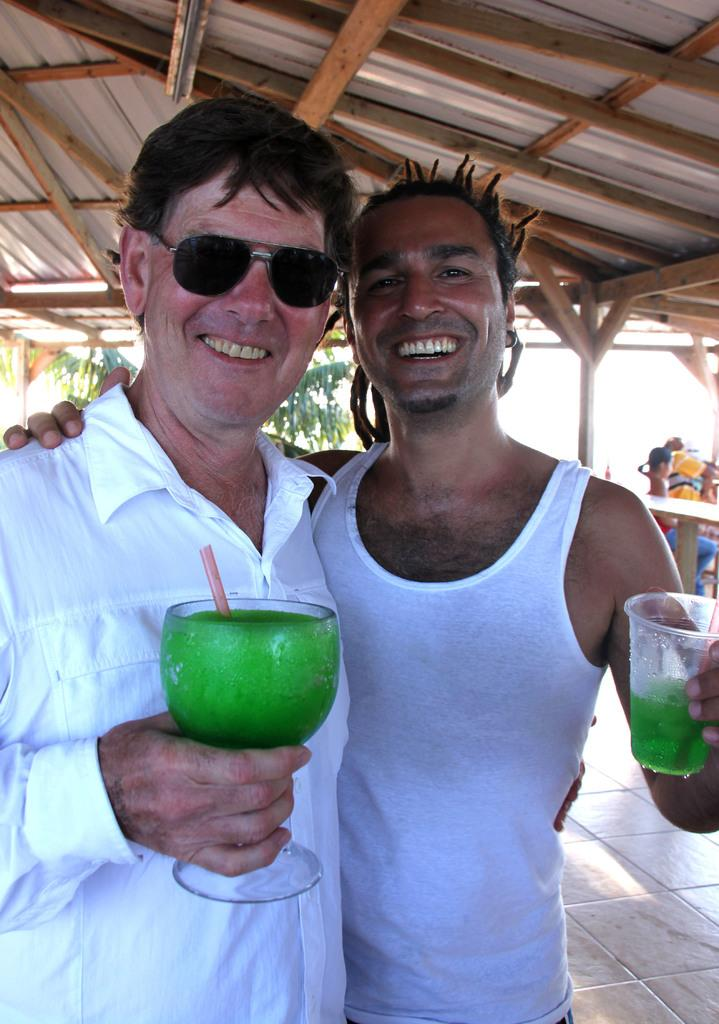How many people are in the image? There are two men in the image. Where are the men located in the image? The men are standing in the middle of the image. What are the men holding in the image? The men are holding green color juice glasses. What is the facial expression of the men in the image? The men are smiling in the image. What are the men doing in the image? The men are giving a pose into the camera. What can be seen above the men in the image? There is a wooden shed visible above the men. What type of amusement can be seen in the image? There is no amusement present in the image; it features two men holding juice glasses and posing for a photo. What type of collar can be seen on the ducks in the image? There are no ducks present in the image, so there is no collar to be seen. 